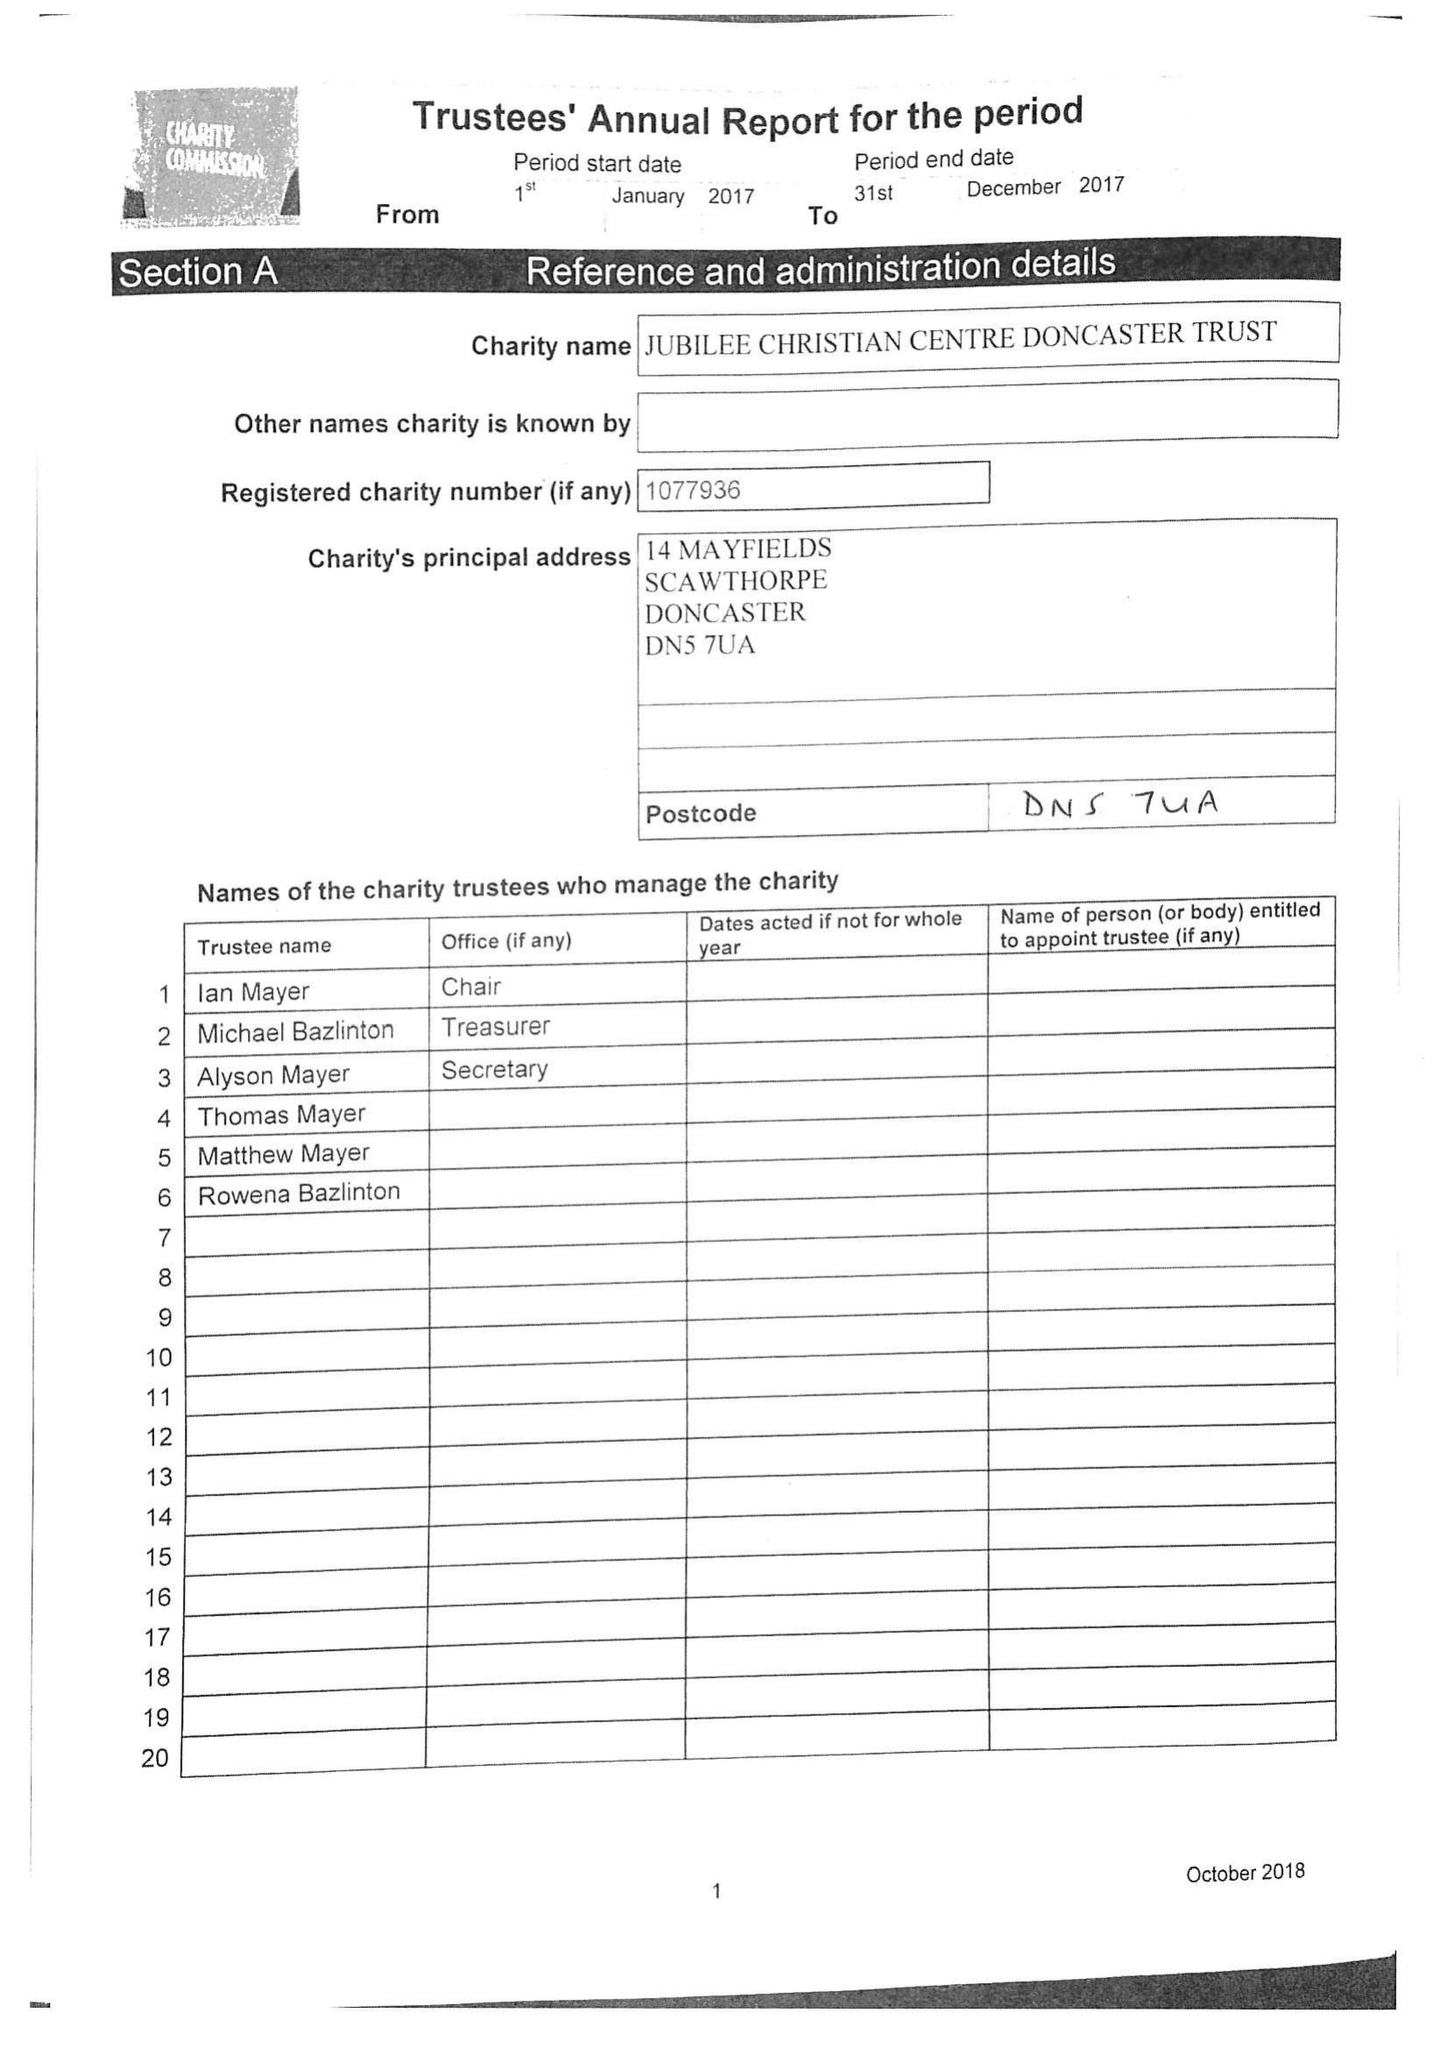What is the value for the charity_name?
Answer the question using a single word or phrase. Jubilee Christian Centre Doncaster Trust 